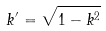Convert formula to latex. <formula><loc_0><loc_0><loc_500><loc_500>k ^ { \prime } = \sqrt { 1 - k ^ { 2 } }</formula> 